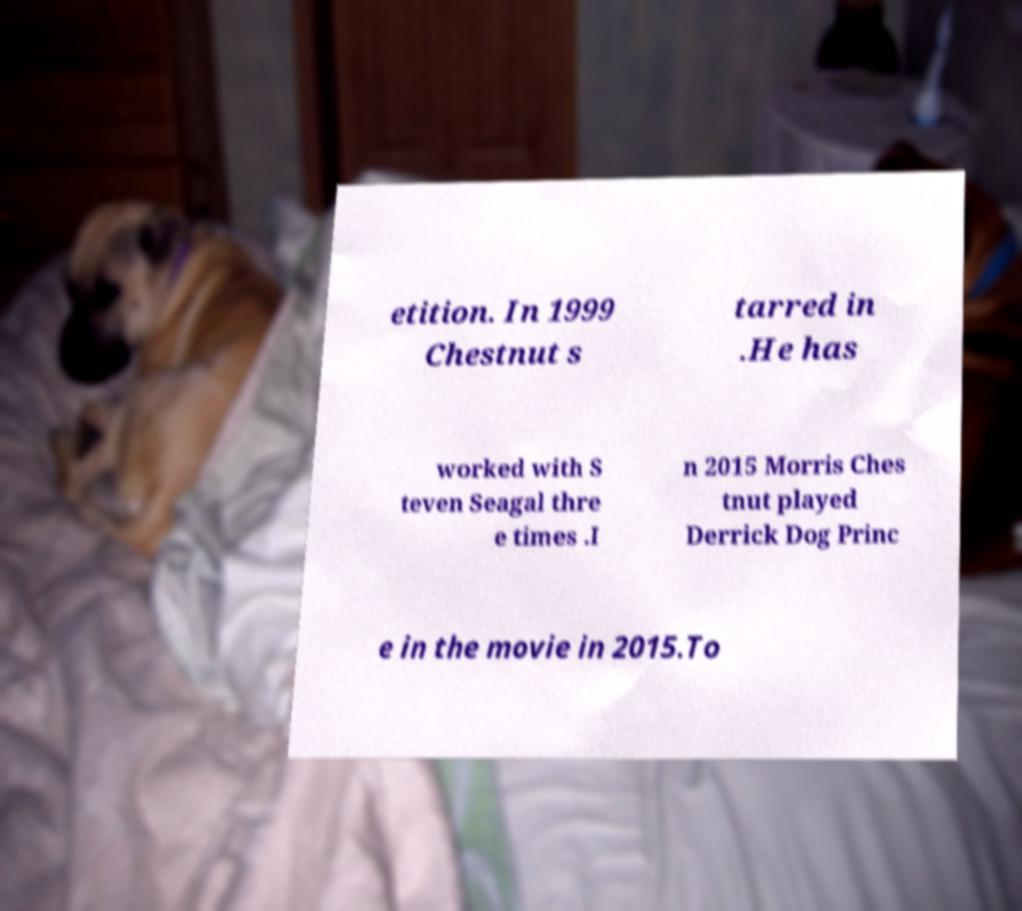Can you accurately transcribe the text from the provided image for me? etition. In 1999 Chestnut s tarred in .He has worked with S teven Seagal thre e times .I n 2015 Morris Ches tnut played Derrick Dog Princ e in the movie in 2015.To 